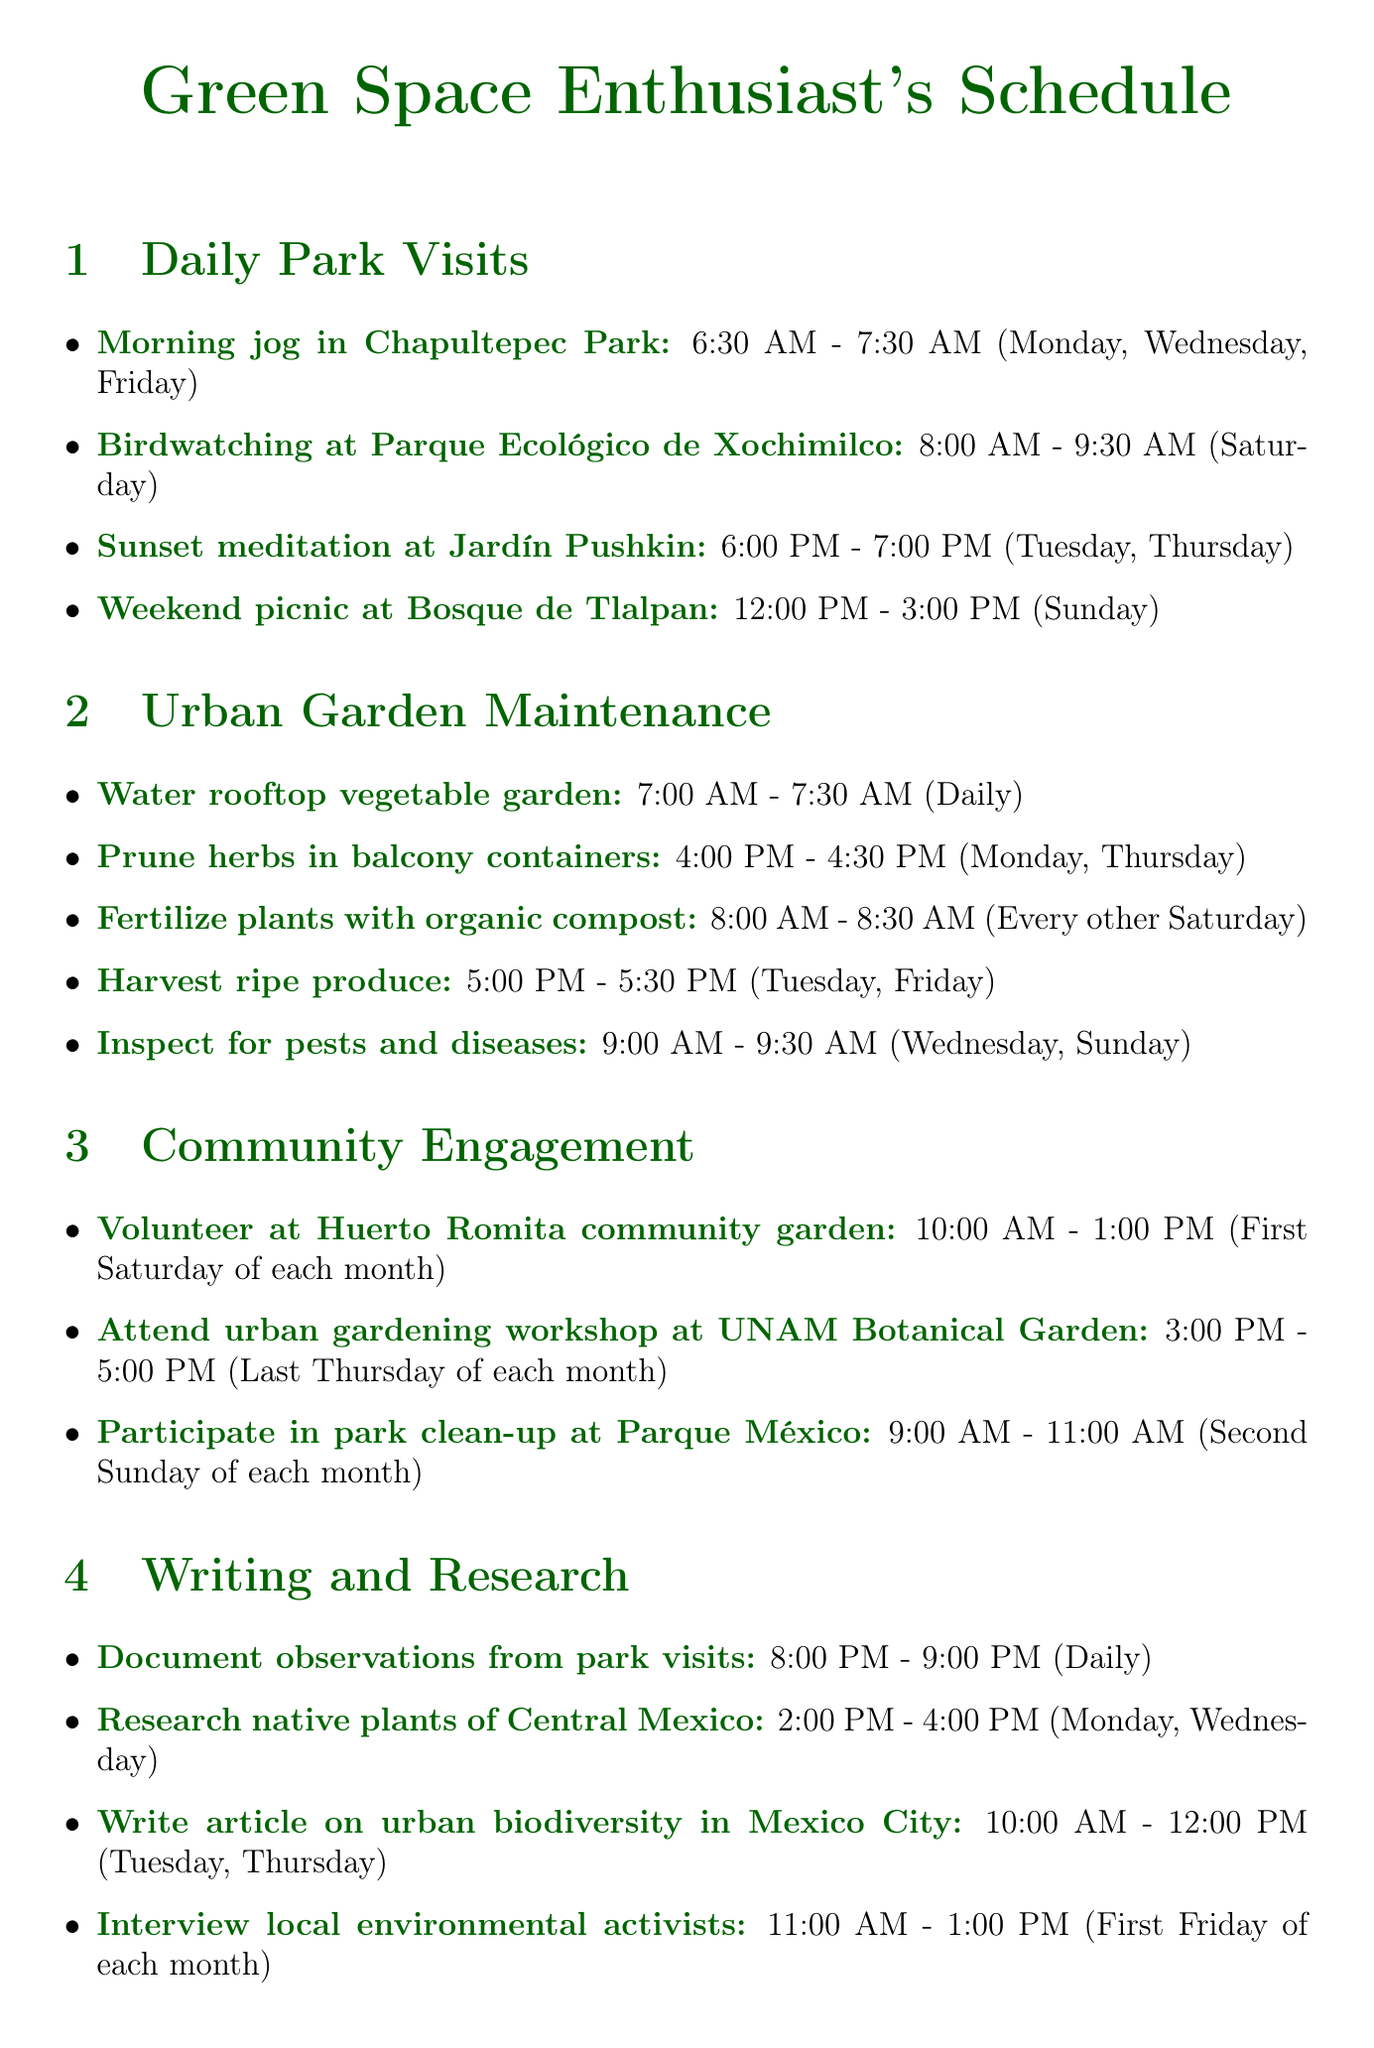what time is the morning jog in Chapultepec Park? The morning jog in Chapultepec Park occurs from 6:30 AM to 7:30 AM.
Answer: 6:30 AM - 7:30 AM which days are designated for birdwatching at Parque Ecológico de Xochimilco? Birdwatching at Parque Ecológico de Xochimilco is scheduled for Saturday.
Answer: Saturday how often do you fertilize plants with organic compost? Fertilizing plants with organic compost takes place every other Saturday.
Answer: Every other Saturday what task is performed at 5:00 PM on Tuesdays? At 5:00 PM on Tuesdays, the task is to harvest ripe produce.
Answer: Harvest ripe produce how many hours does the community garden volunteering last? The community garden volunteering lasts for 3 hours, from 10:00 AM to 1:00 PM.
Answer: 3 hours which activity occurs on the last Thursday of each month? The activity on the last Thursday of each month is an urban gardening workshop at UNAM Botanical Garden.
Answer: Attend urban gardening workshop at UNAM Botanical Garden what is done daily at 8:00 PM? At 8:00 PM daily, observations from park visits are documented.
Answer: Document observations from park visits when are the park clean-up events held? Park clean-up events are held on the second Sunday of each month.
Answer: Second Sunday of each month 